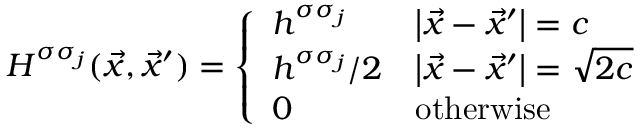<formula> <loc_0><loc_0><loc_500><loc_500>H ^ { \sigma \sigma _ { j } } ( { \vec { x } } , { \vec { x } } ^ { \prime } ) = { \left \{ \begin{array} { l l } { h ^ { \sigma \sigma _ { j } } } & { \left | { \vec { x } } - { \vec { x } } ^ { \prime } \right | = c } \\ { h ^ { \sigma \sigma _ { j } } / 2 } & { \left | { \vec { x } } - { \vec { x } } ^ { \prime } \right | = { \sqrt { 2 c } } } \\ { 0 } & { o t h e r w i s e } \end{array} }</formula> 